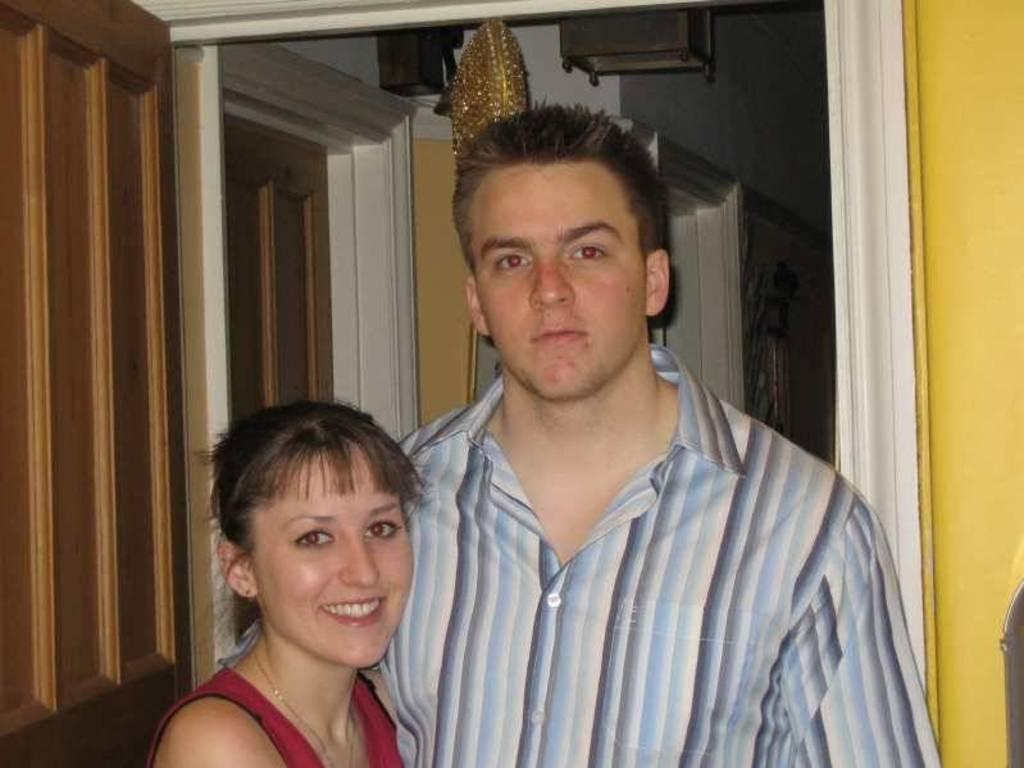Who are the two people in the image? There is a man and a lady standing in the center of the image. What can be seen in the background of the image? There are doors and a wall in the background of the image. How many lizards are crawling on the wall in the image? There are no lizards visible in the image; only the man, the lady, the doors, and the wall can be seen. 